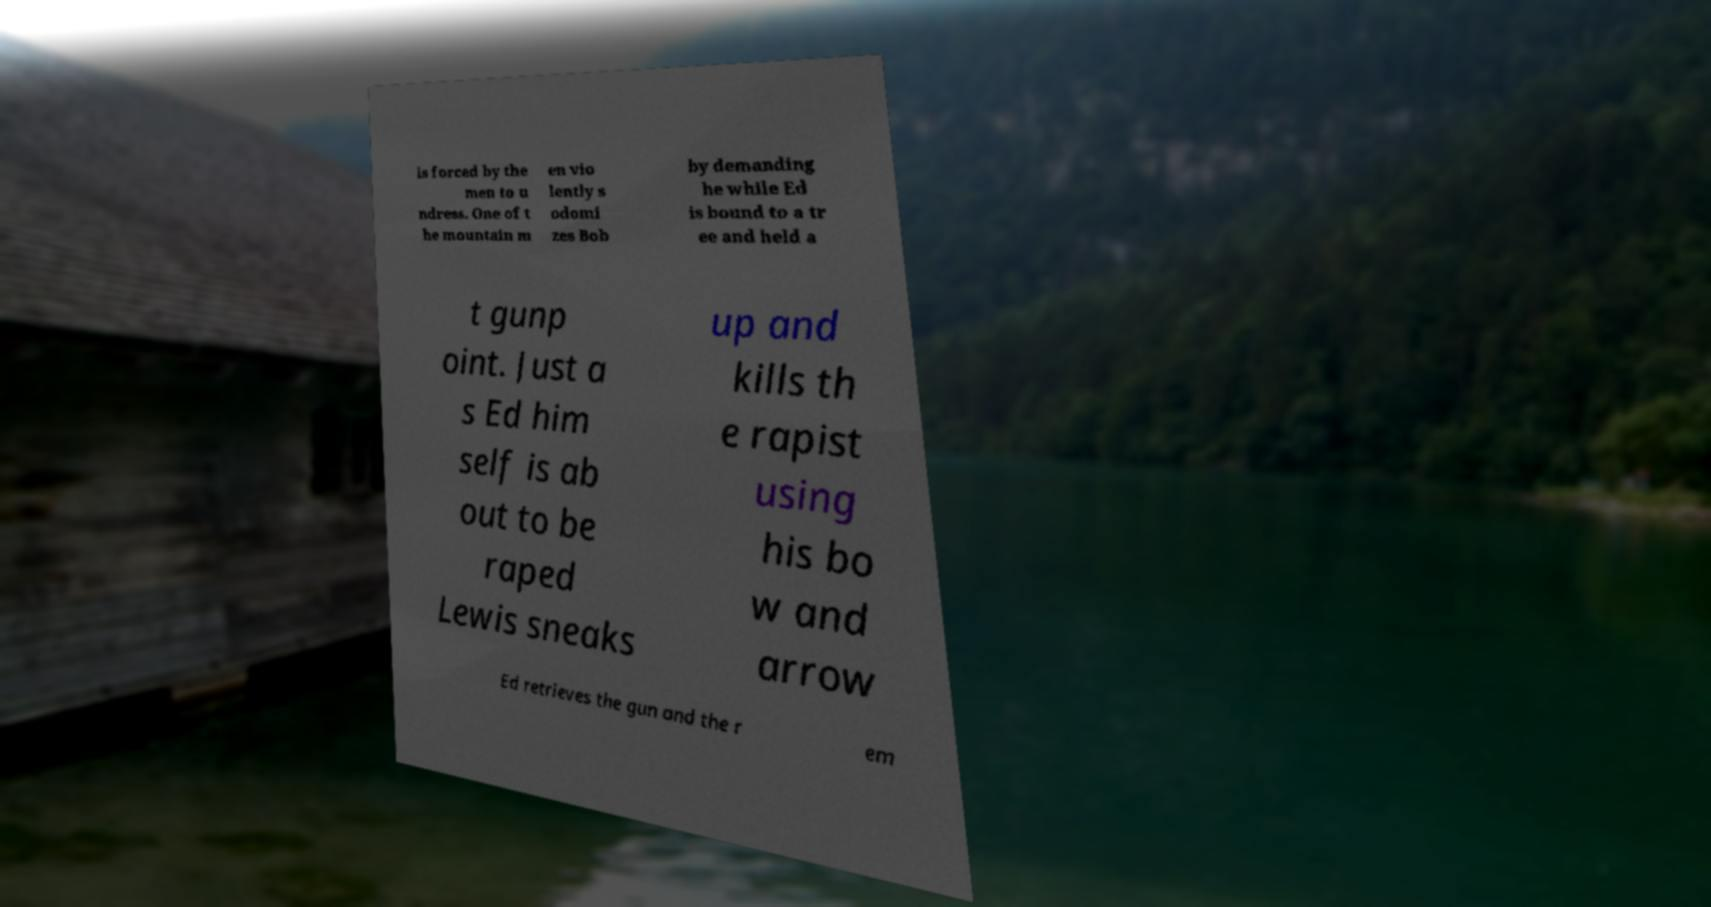I need the written content from this picture converted into text. Can you do that? is forced by the men to u ndress. One of t he mountain m en vio lently s odomi zes Bob by demanding he while Ed is bound to a tr ee and held a t gunp oint. Just a s Ed him self is ab out to be raped Lewis sneaks up and kills th e rapist using his bo w and arrow Ed retrieves the gun and the r em 